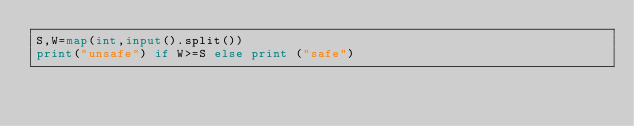<code> <loc_0><loc_0><loc_500><loc_500><_Python_>S,W=map(int,input().split())
print("unsafe") if W>=S else print ("safe")</code> 